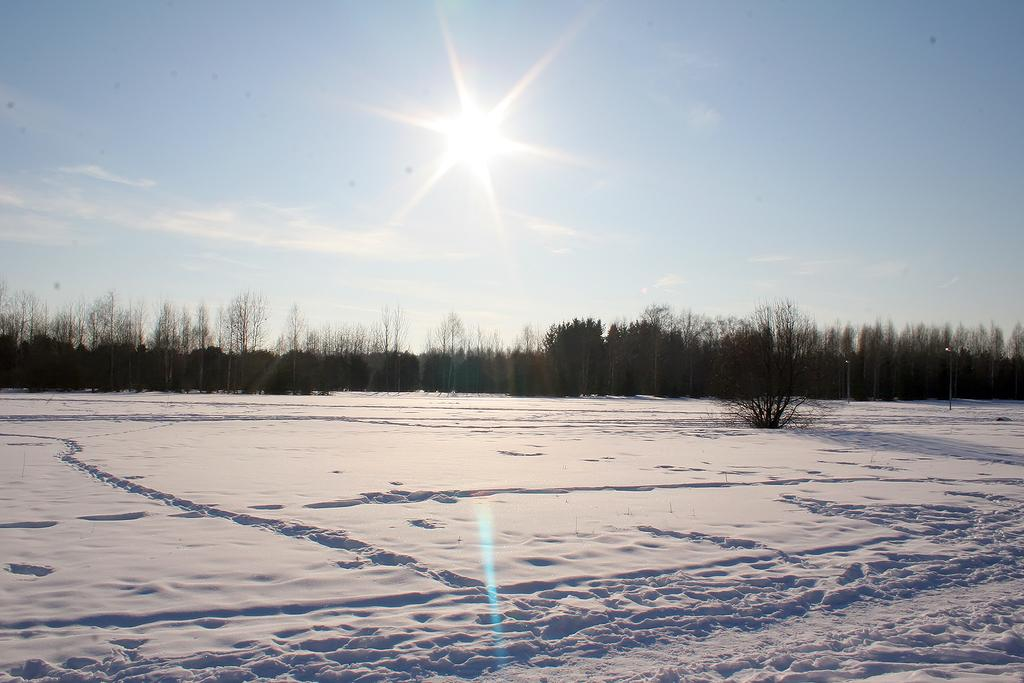What type of vegetation can be seen in the image? There are trees in the image. What is the weather like in the image? There is snow in the image, indicating a cold and likely wintery scene. What can be seen in the background of the image? The sky is visible in the background of the image. Can the sun be seen in the image? Yes, the sun is observable in the sky. How many frogs are sitting on the branches of the trees in the image? There are no frogs present in the image; it only features trees and snow. 